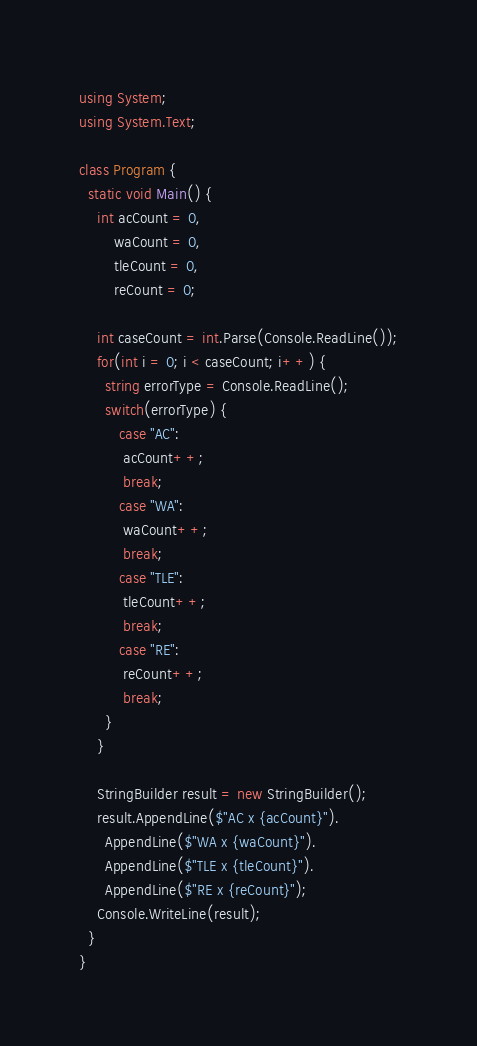Convert code to text. <code><loc_0><loc_0><loc_500><loc_500><_C#_>using System;
using System.Text;
 
class Program {
  static void Main() {
    int acCount = 0,
        waCount = 0,
        tleCount = 0,
        reCount = 0;
    
    int caseCount = int.Parse(Console.ReadLine());
    for(int i = 0; i < caseCount; i++) {
      string errorType = Console.ReadLine();
      switch(errorType) {
         case "AC":
          acCount++;
          break;
         case "WA":
          waCount++;
          break;
         case "TLE":
          tleCount++;
          break;
         case "RE":
          reCount++;
          break;
      }
    }
    
    StringBuilder result = new StringBuilder();
    result.AppendLine($"AC x {acCount}").
      AppendLine($"WA x {waCount}").
      AppendLine($"TLE x {tleCount}").
      AppendLine($"RE x {reCount}");
    Console.WriteLine(result);
  }
}
</code> 